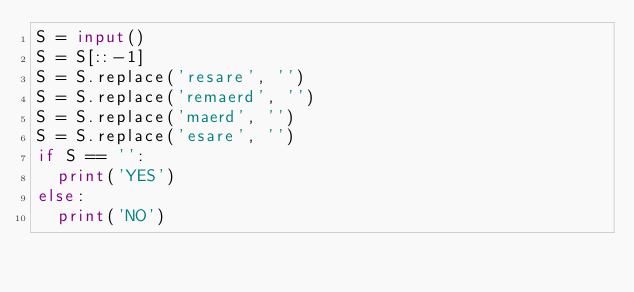<code> <loc_0><loc_0><loc_500><loc_500><_Python_>S = input()
S = S[::-1]
S = S.replace('resare', '')
S = S.replace('remaerd', '')
S = S.replace('maerd', '')
S = S.replace('esare', '')
if S == '':
  print('YES')
else:
  print('NO')</code> 